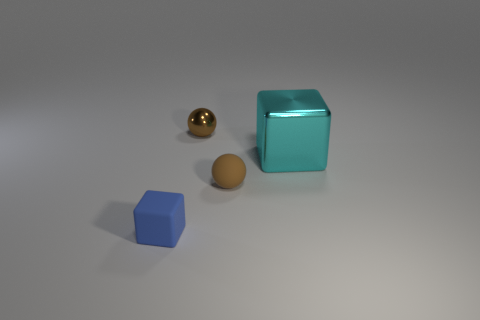Are there any other things that are the same size as the metal cube?
Provide a succinct answer. No. Do the blue rubber block and the brown sphere in front of the tiny brown shiny thing have the same size?
Provide a succinct answer. Yes. Is there a object that has the same color as the tiny shiny sphere?
Make the answer very short. Yes. How many brown balls are behind the shiny sphere?
Give a very brief answer. 0. What is the material of the small thing that is to the left of the brown rubber object and behind the blue thing?
Provide a succinct answer. Metal. How many cyan shiny blocks have the same size as the brown metal ball?
Offer a terse response. 0. There is a tiny metallic object on the left side of the metallic thing on the right side of the metallic sphere; what color is it?
Provide a short and direct response. Brown. Are there any big blue rubber cylinders?
Offer a very short reply. No. Does the cyan thing have the same shape as the blue thing?
Ensure brevity in your answer.  Yes. What is the size of the thing that is the same color as the rubber ball?
Your answer should be very brief. Small. 